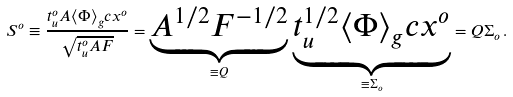<formula> <loc_0><loc_0><loc_500><loc_500>S ^ { o } \equiv \frac { t _ { u } ^ { o } A \langle \Phi \rangle _ { g } c x ^ { o } } { \sqrt { t _ { u } ^ { o } A F } } = \underbrace { A ^ { 1 / 2 } F ^ { - 1 / 2 } } _ { \equiv Q } \, \underbrace { t _ { u } ^ { 1 / 2 } \langle \Phi \rangle _ { g } c x ^ { o } } _ { \equiv \Sigma _ { o } } = Q \Sigma _ { o } \, .</formula> 